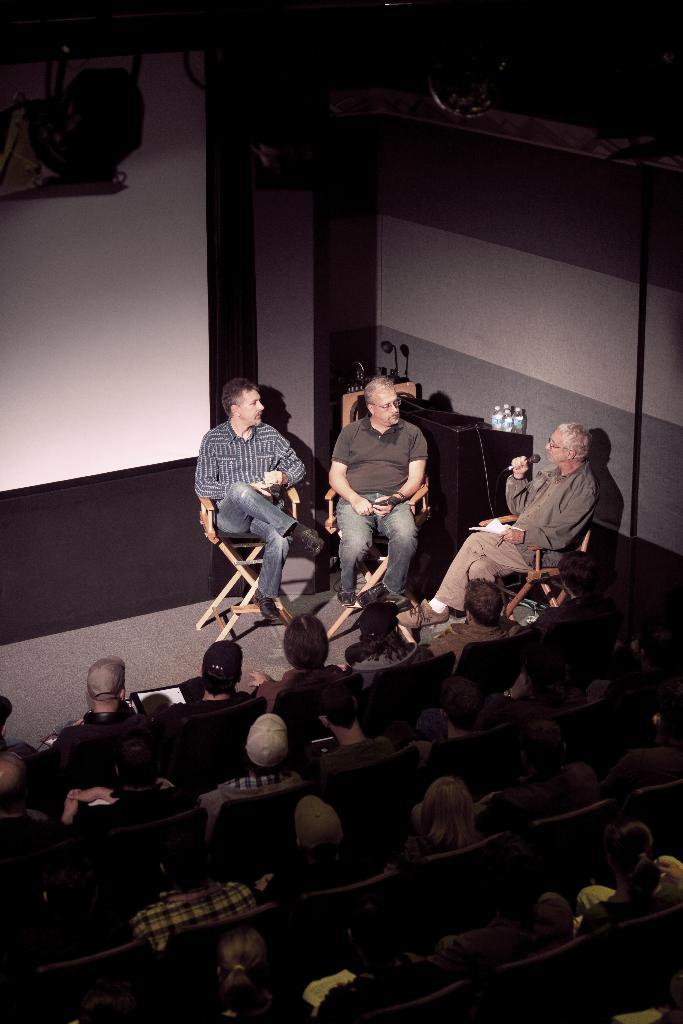How many people are in the image? There are many people in the image. What are the people wearing? The people are wearing clothes. What are the people doing in the image? The people are sitting on chairs. What object is used for amplifying sound in the image? There is a microphone in the image. What type of writing surface is present in the image? There is a whiteboard in the image. What can be seen on the floor in the image? The floor is visible in the image. What type of tank can be seen in the image? There is no tank present in the image. Is it raining in the image? There is no indication of rain in the image. 